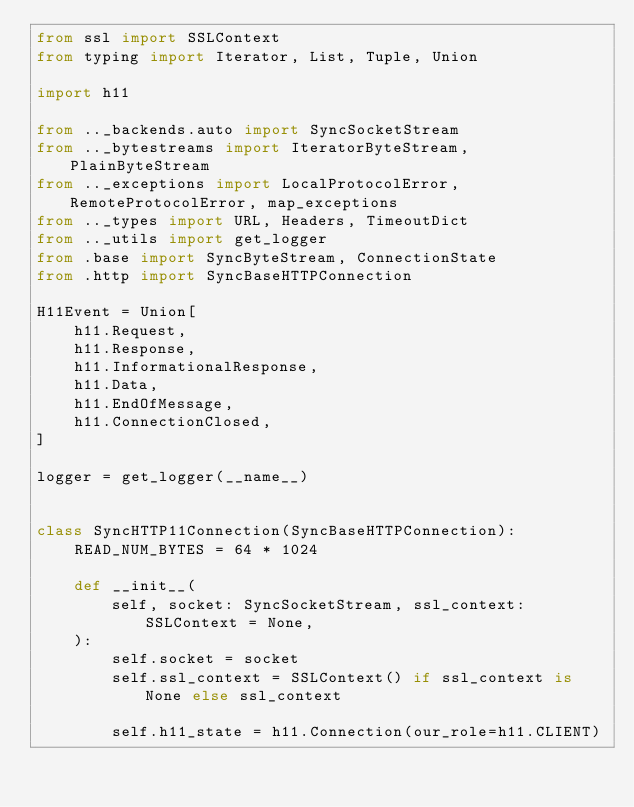<code> <loc_0><loc_0><loc_500><loc_500><_Python_>from ssl import SSLContext
from typing import Iterator, List, Tuple, Union

import h11

from .._backends.auto import SyncSocketStream
from .._bytestreams import IteratorByteStream, PlainByteStream
from .._exceptions import LocalProtocolError, RemoteProtocolError, map_exceptions
from .._types import URL, Headers, TimeoutDict
from .._utils import get_logger
from .base import SyncByteStream, ConnectionState
from .http import SyncBaseHTTPConnection

H11Event = Union[
    h11.Request,
    h11.Response,
    h11.InformationalResponse,
    h11.Data,
    h11.EndOfMessage,
    h11.ConnectionClosed,
]

logger = get_logger(__name__)


class SyncHTTP11Connection(SyncBaseHTTPConnection):
    READ_NUM_BYTES = 64 * 1024

    def __init__(
        self, socket: SyncSocketStream, ssl_context: SSLContext = None,
    ):
        self.socket = socket
        self.ssl_context = SSLContext() if ssl_context is None else ssl_context

        self.h11_state = h11.Connection(our_role=h11.CLIENT)
</code> 